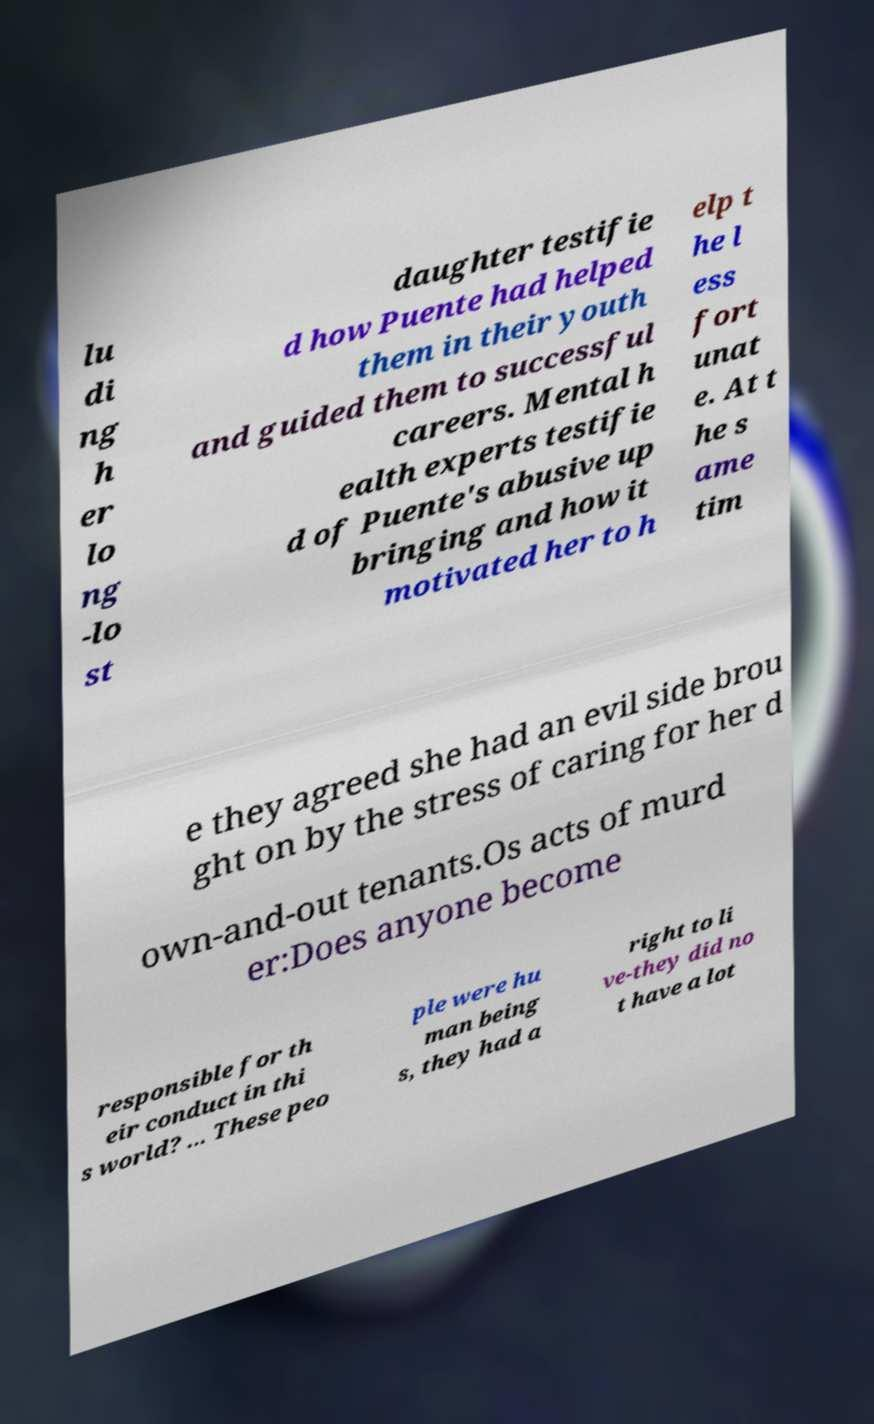There's text embedded in this image that I need extracted. Can you transcribe it verbatim? lu di ng h er lo ng -lo st daughter testifie d how Puente had helped them in their youth and guided them to successful careers. Mental h ealth experts testifie d of Puente's abusive up bringing and how it motivated her to h elp t he l ess fort unat e. At t he s ame tim e they agreed she had an evil side brou ght on by the stress of caring for her d own-and-out tenants.Os acts of murd er:Does anyone become responsible for th eir conduct in thi s world? ... These peo ple were hu man being s, they had a right to li ve-they did no t have a lot 